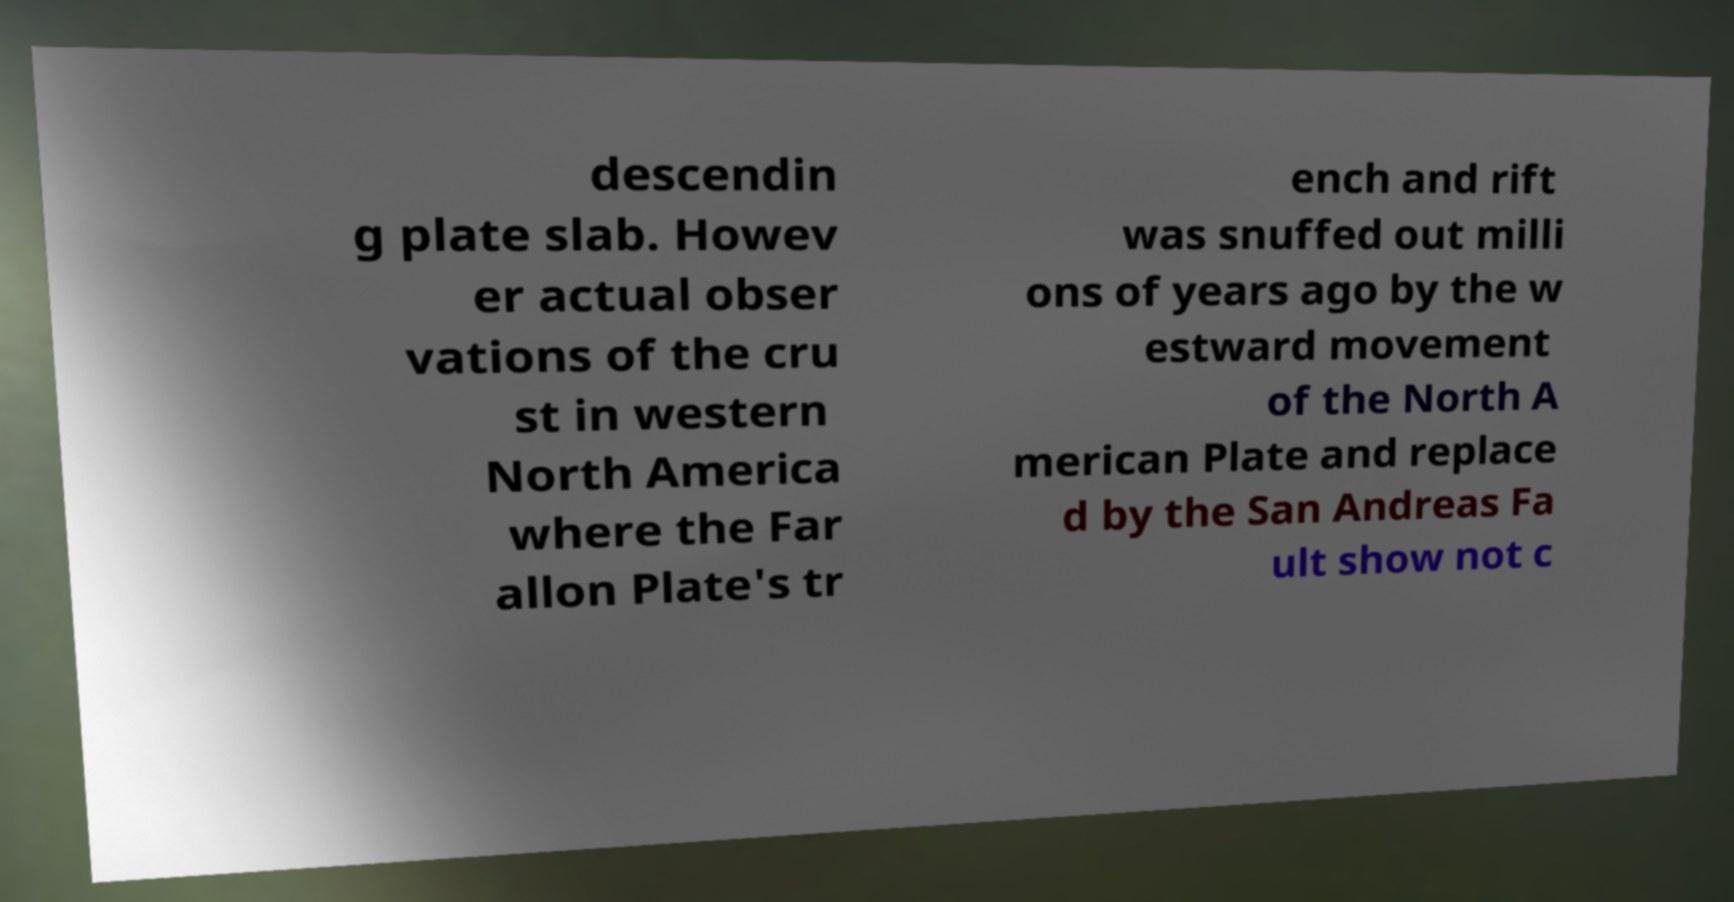Can you read and provide the text displayed in the image?This photo seems to have some interesting text. Can you extract and type it out for me? descendin g plate slab. Howev er actual obser vations of the cru st in western North America where the Far allon Plate's tr ench and rift was snuffed out milli ons of years ago by the w estward movement of the North A merican Plate and replace d by the San Andreas Fa ult show not c 